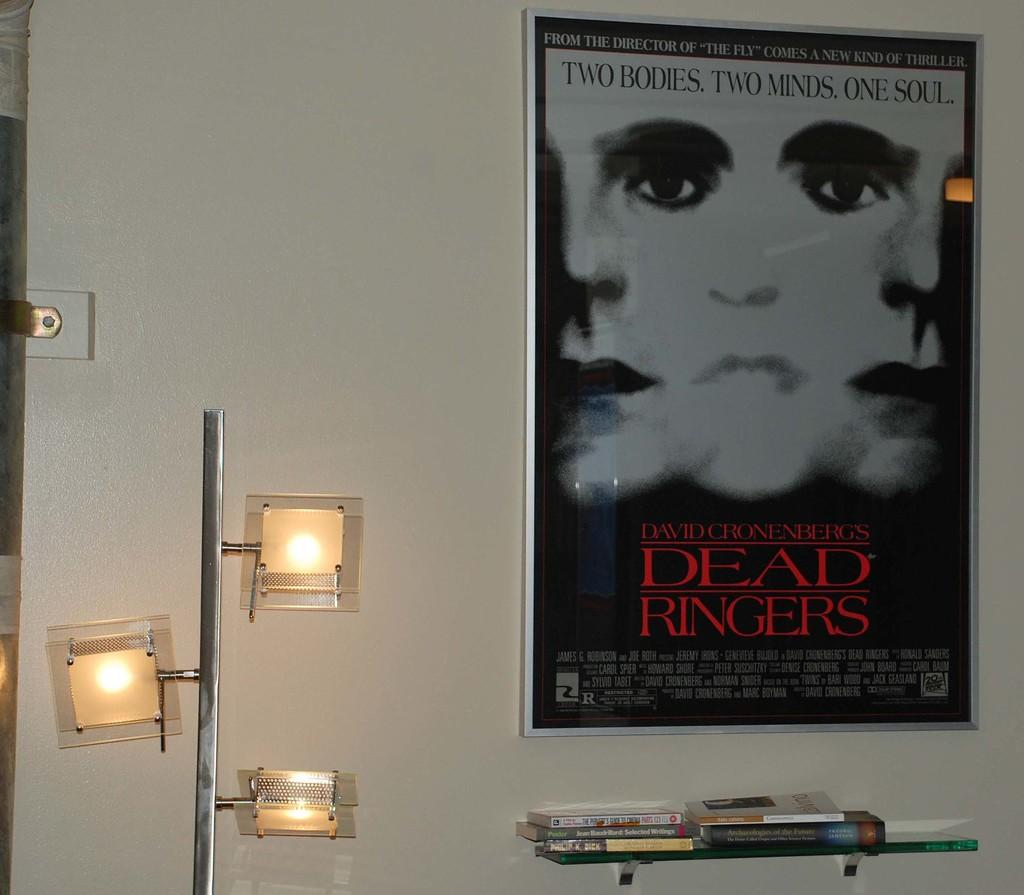<image>
Render a clear and concise summary of the photo. on the white wall hangs a movie poster from the movie Dead ringers 